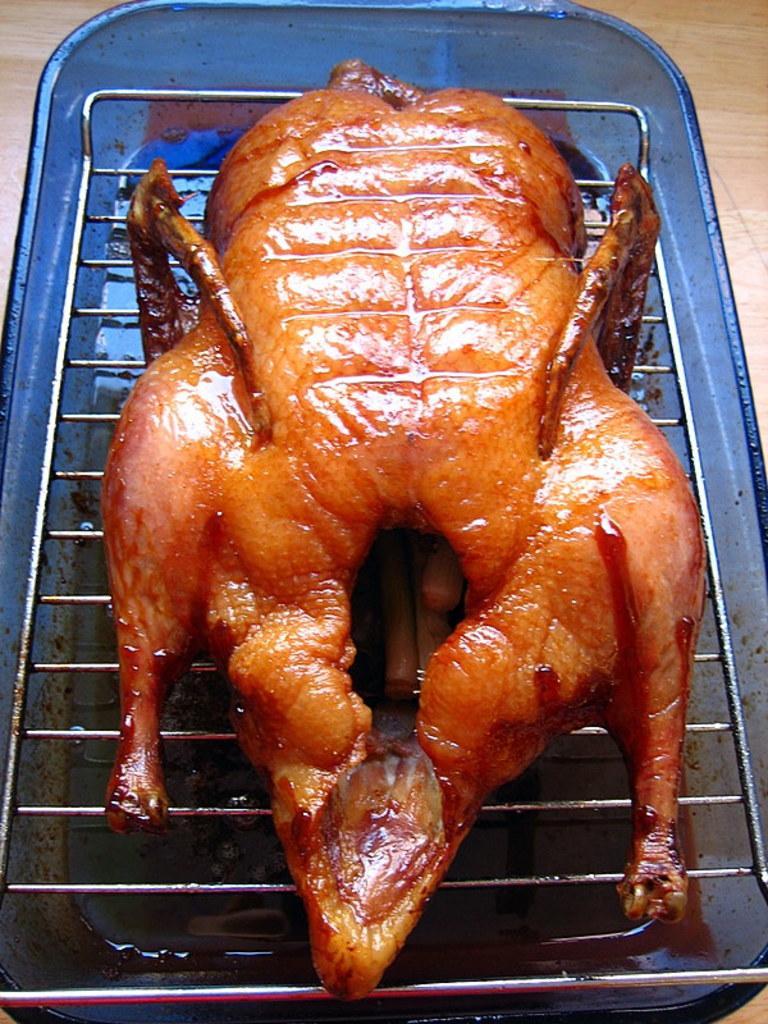How would you summarize this image in a sentence or two? In the center of the image we can see chicken on the grill. 